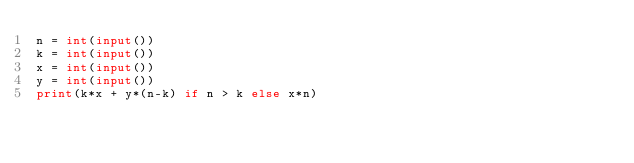<code> <loc_0><loc_0><loc_500><loc_500><_Python_>n = int(input())
k = int(input())
x = int(input())
y = int(input())
print(k*x + y*(n-k) if n > k else x*n)
</code> 